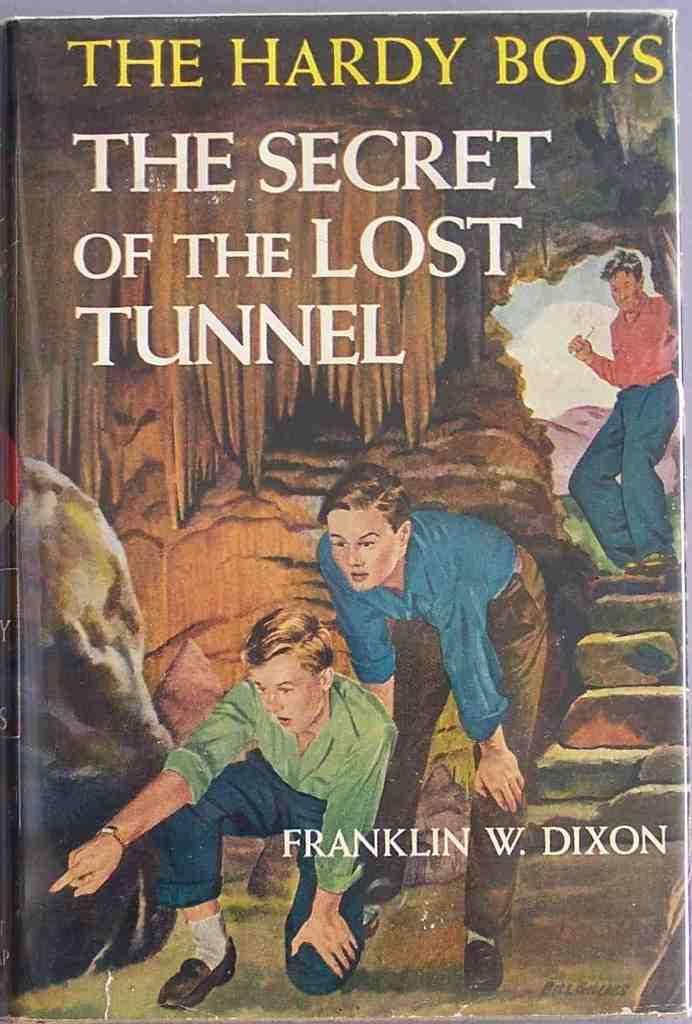<image>
Offer a succinct explanation of the picture presented. A book series named The Hardy Boys by Franklin W. Dixon. 